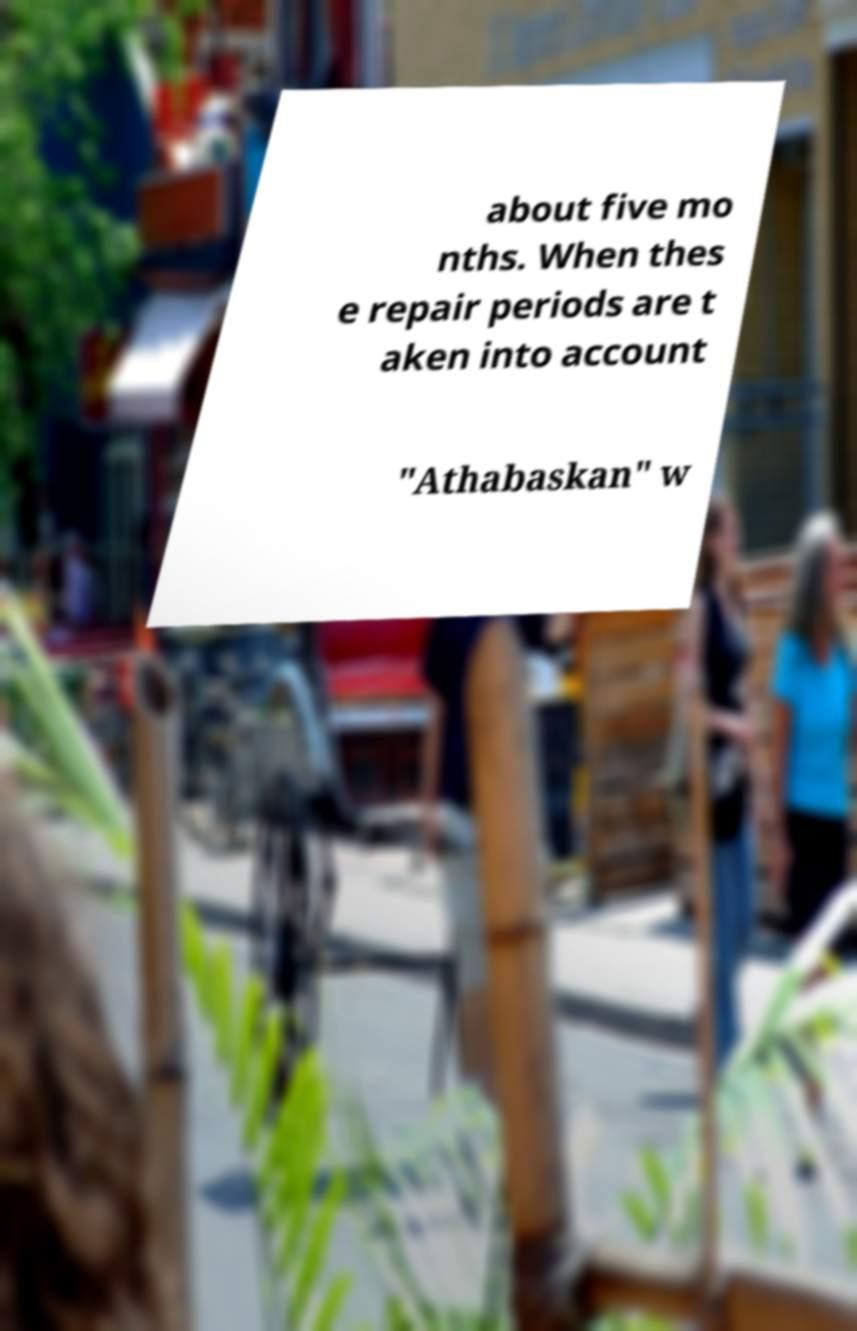Please read and relay the text visible in this image. What does it say? about five mo nths. When thes e repair periods are t aken into account "Athabaskan" w 